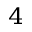<formula> <loc_0><loc_0><loc_500><loc_500>_ { 4 }</formula> 